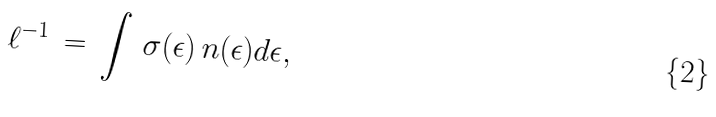<formula> <loc_0><loc_0><loc_500><loc_500>\ell ^ { - 1 } \, = \, \int \, \sigma ( \epsilon ) \, n ( \epsilon ) d \epsilon ,</formula> 